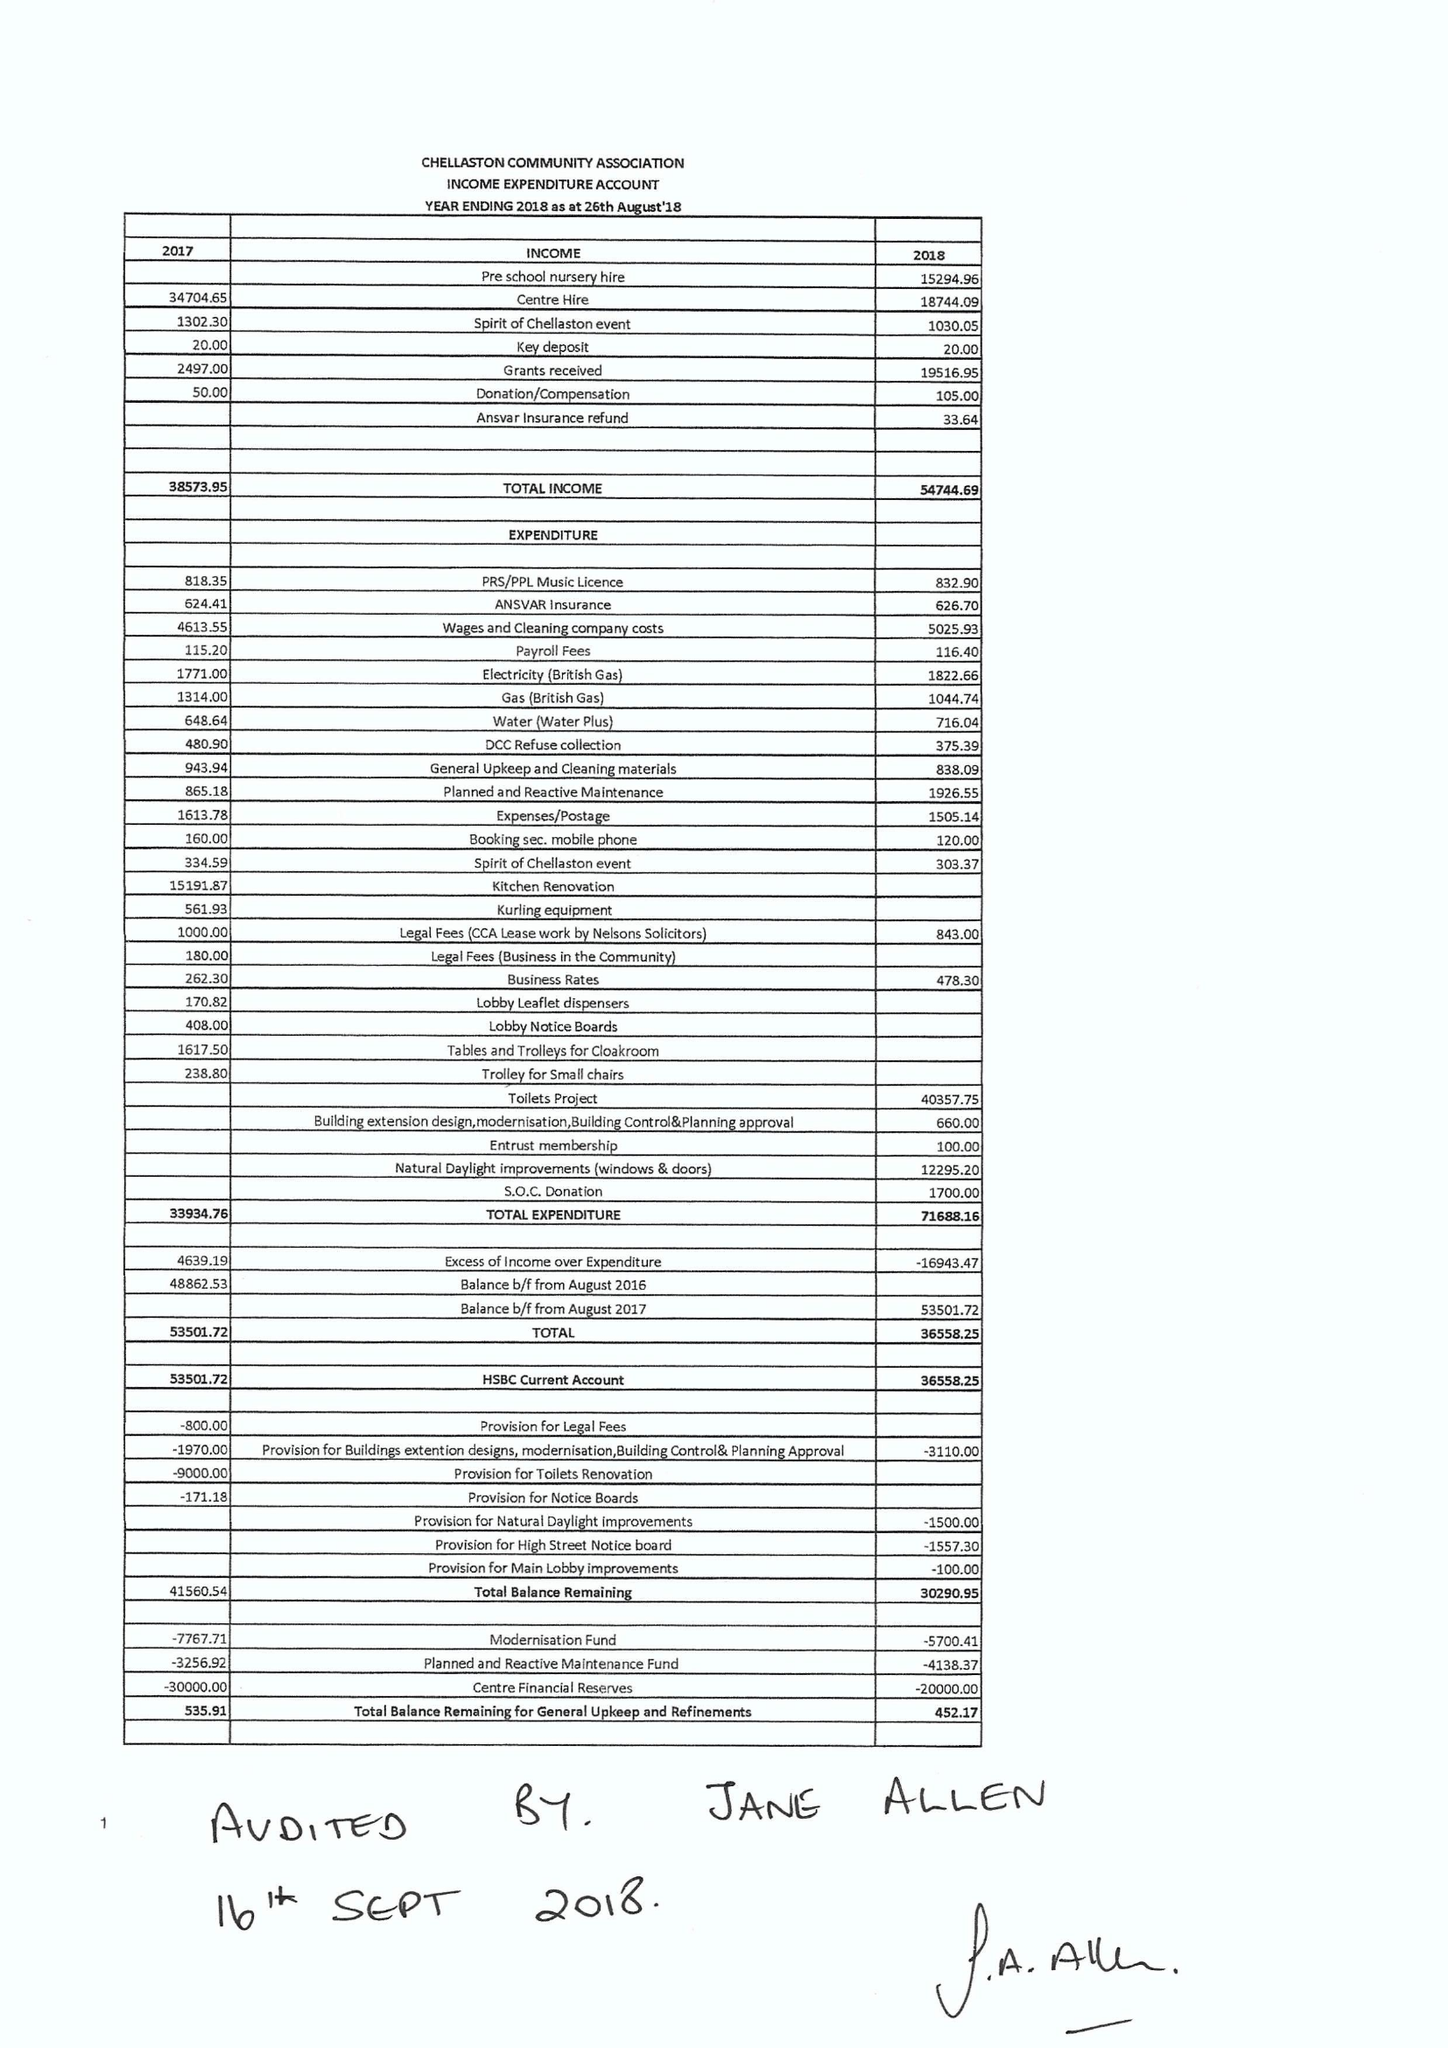What is the value for the report_date?
Answer the question using a single word or phrase. 2018-08-26 